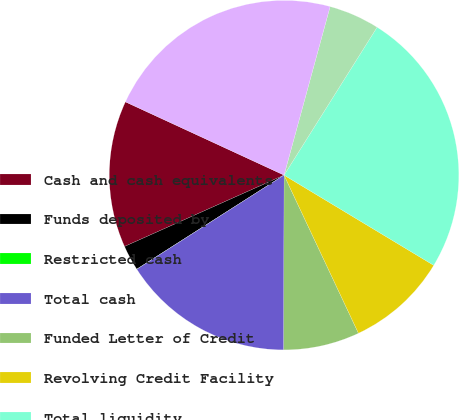Convert chart. <chart><loc_0><loc_0><loc_500><loc_500><pie_chart><fcel>Cash and cash equivalents<fcel>Funds deposited by<fcel>Restricted cash<fcel>Total cash<fcel>Funded Letter of Credit<fcel>Revolving Credit Facility<fcel>Total liquidity<fcel>Less Funds deposited as<fcel>Total liquidity excluding<nl><fcel>13.58%<fcel>2.35%<fcel>0.01%<fcel>15.92%<fcel>7.03%<fcel>9.37%<fcel>24.7%<fcel>4.69%<fcel>22.36%<nl></chart> 